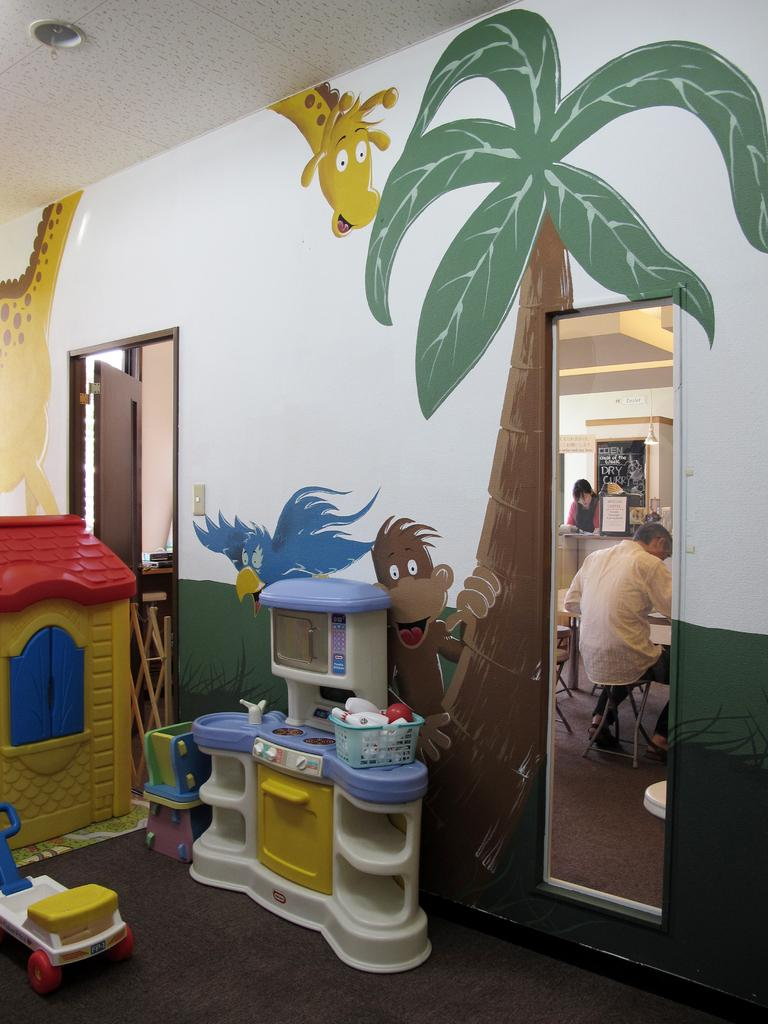What type of space is shown in the image? The image is an inside view of a room. What can be seen on the walls of the room? There are paintings on the wall. How can one enter or exit the room? There is a door in the room. What is present on the floor of the room? There are objects on the floor. What is used for reflecting images in the room? There is a mirror on the wall with reflections. What provides illumination in the room? There is light on the ceiling. How many divisions are there in the picture hanging on the wall? There is no picture mentioned in the facts, only paintings on the wall. Additionally, the concept of divisions in a picture is not applicable to the given facts. 